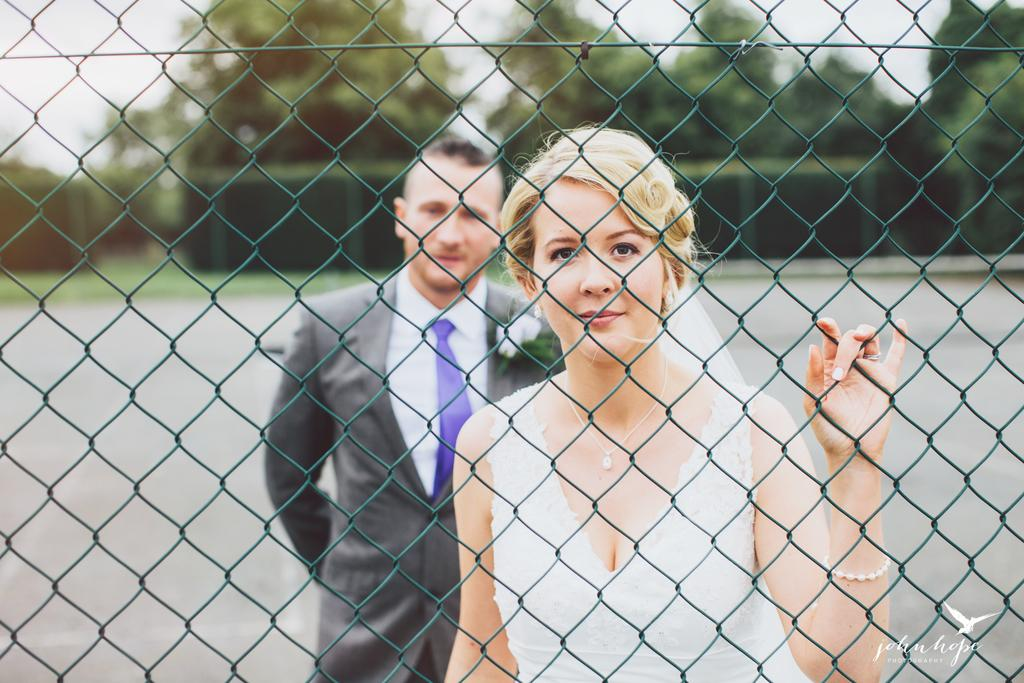How many people are present in the image? There is a man and a woman standing in the image. What can be seen in the background of the image? There are trees in the background of the image. Is there any architectural feature visible in the image? Yes, there appears to be a fence in the image. What is present at the bottom of the image? There is a watermark at the bottom of the image. What type of club is the man holding in the image? There is no club present in the image; the man is not holding anything. 